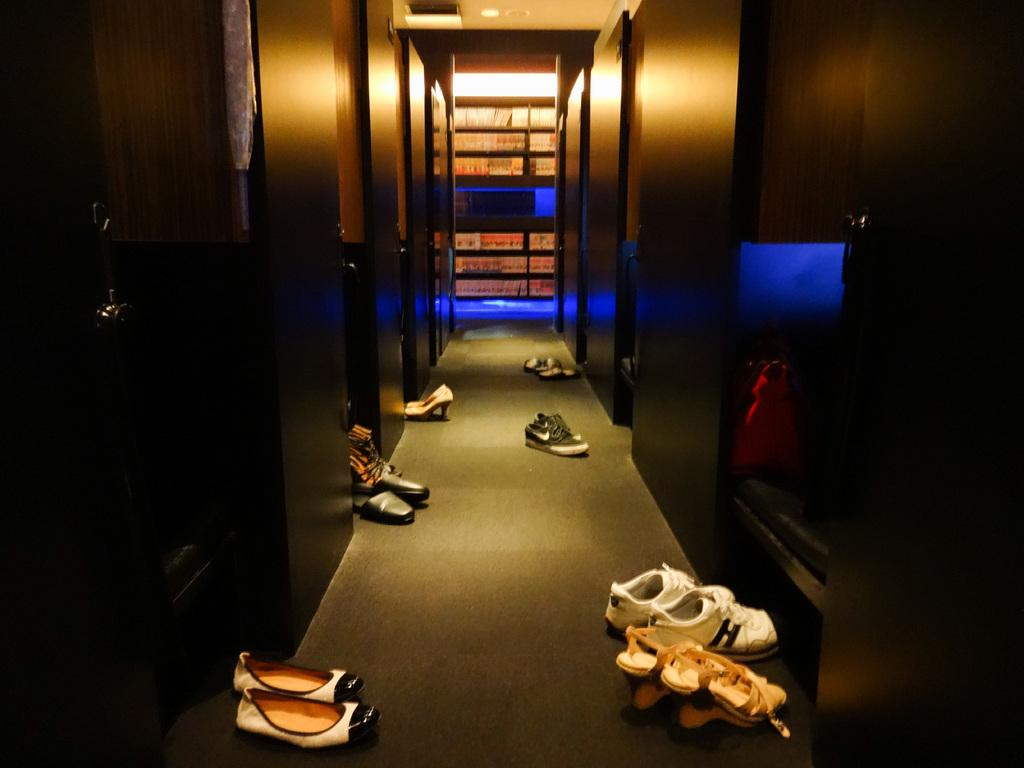What is the main feature of the image? The image appears to depict a corridor with many doors. What can be found on the floor at the bottom of the image? There are shoes on the floor at the bottom of the image. What is visible in the background of the image? A rack is visible in the background of the image. What is present at the top of the image? There is a roof at the top of the image. Where is the glove placed in the image? There is no glove present in the image. What advice does the grandfather give to the person in the image? There is no grandfather or person present in the image. 